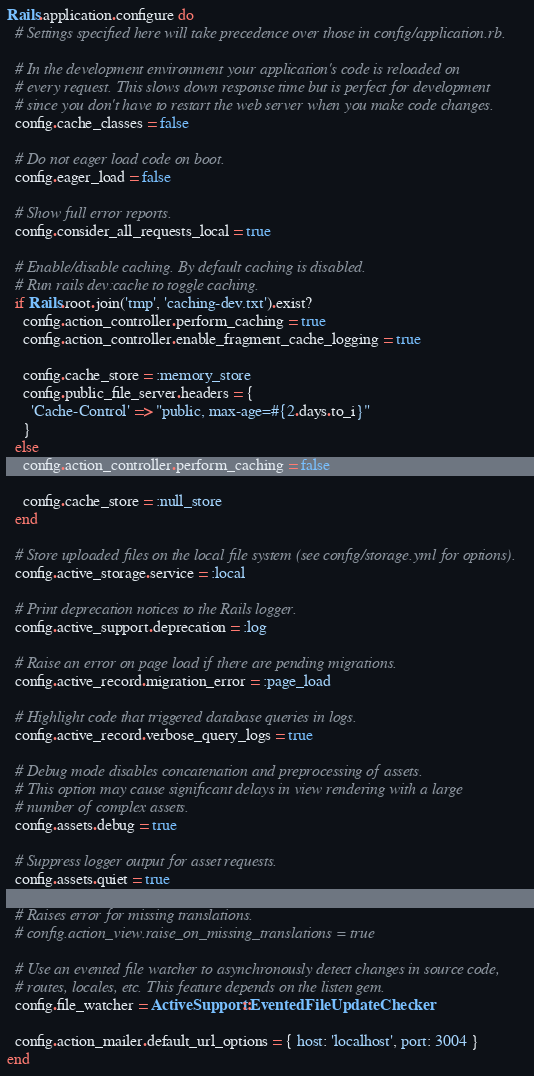Convert code to text. <code><loc_0><loc_0><loc_500><loc_500><_Ruby_>Rails.application.configure do
  # Settings specified here will take precedence over those in config/application.rb.

  # In the development environment your application's code is reloaded on
  # every request. This slows down response time but is perfect for development
  # since you don't have to restart the web server when you make code changes.
  config.cache_classes = false

  # Do not eager load code on boot.
  config.eager_load = false

  # Show full error reports.
  config.consider_all_requests_local = true

  # Enable/disable caching. By default caching is disabled.
  # Run rails dev:cache to toggle caching.
  if Rails.root.join('tmp', 'caching-dev.txt').exist?
    config.action_controller.perform_caching = true
    config.action_controller.enable_fragment_cache_logging = true

    config.cache_store = :memory_store
    config.public_file_server.headers = {
      'Cache-Control' => "public, max-age=#{2.days.to_i}"
    }
  else
    config.action_controller.perform_caching = false

    config.cache_store = :null_store
  end

  # Store uploaded files on the local file system (see config/storage.yml for options).
  config.active_storage.service = :local

  # Print deprecation notices to the Rails logger.
  config.active_support.deprecation = :log

  # Raise an error on page load if there are pending migrations.
  config.active_record.migration_error = :page_load

  # Highlight code that triggered database queries in logs.
  config.active_record.verbose_query_logs = true

  # Debug mode disables concatenation and preprocessing of assets.
  # This option may cause significant delays in view rendering with a large
  # number of complex assets.
  config.assets.debug = true

  # Suppress logger output for asset requests.
  config.assets.quiet = true

  # Raises error for missing translations.
  # config.action_view.raise_on_missing_translations = true

  # Use an evented file watcher to asynchronously detect changes in source code,
  # routes, locales, etc. This feature depends on the listen gem.
  config.file_watcher = ActiveSupport::EventedFileUpdateChecker

  config.action_mailer.default_url_options = { host: 'localhost', port: 3004 }
end
</code> 